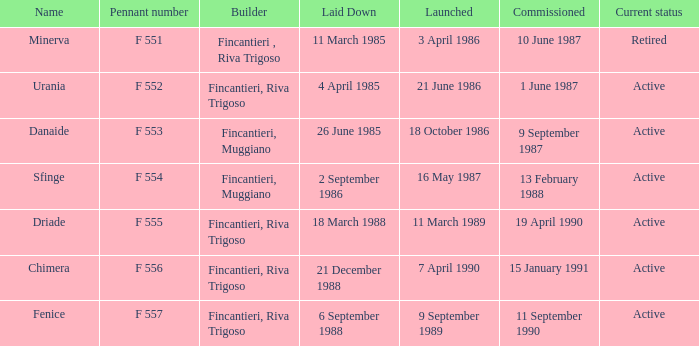On which date was the driade launched? 11 March 1989. 